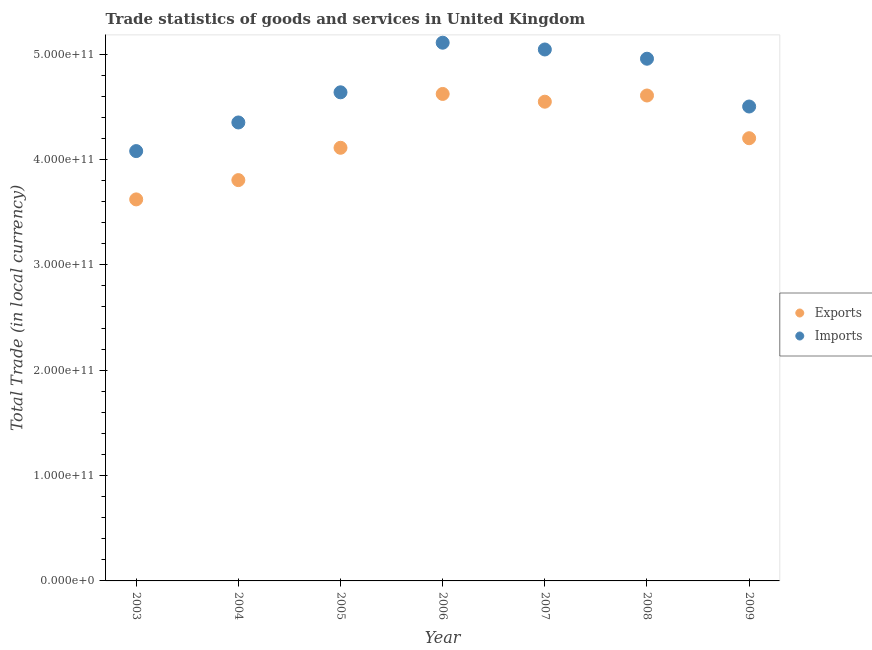What is the export of goods and services in 2008?
Make the answer very short. 4.61e+11. Across all years, what is the maximum export of goods and services?
Your answer should be very brief. 4.62e+11. Across all years, what is the minimum export of goods and services?
Give a very brief answer. 3.62e+11. In which year was the imports of goods and services maximum?
Your response must be concise. 2006. What is the total imports of goods and services in the graph?
Keep it short and to the point. 3.27e+12. What is the difference between the export of goods and services in 2006 and that in 2009?
Ensure brevity in your answer.  4.20e+1. What is the difference between the export of goods and services in 2007 and the imports of goods and services in 2006?
Your answer should be compact. -5.60e+1. What is the average export of goods and services per year?
Your response must be concise. 4.22e+11. In the year 2009, what is the difference between the export of goods and services and imports of goods and services?
Provide a succinct answer. -3.01e+1. In how many years, is the export of goods and services greater than 180000000000 LCU?
Ensure brevity in your answer.  7. What is the ratio of the export of goods and services in 2003 to that in 2004?
Give a very brief answer. 0.95. Is the export of goods and services in 2005 less than that in 2009?
Keep it short and to the point. Yes. Is the difference between the export of goods and services in 2004 and 2009 greater than the difference between the imports of goods and services in 2004 and 2009?
Offer a terse response. No. What is the difference between the highest and the second highest imports of goods and services?
Make the answer very short. 6.43e+09. What is the difference between the highest and the lowest export of goods and services?
Your answer should be very brief. 1.00e+11. Is the export of goods and services strictly greater than the imports of goods and services over the years?
Keep it short and to the point. No. How many dotlines are there?
Your answer should be compact. 2. What is the difference between two consecutive major ticks on the Y-axis?
Provide a succinct answer. 1.00e+11. Does the graph contain any zero values?
Give a very brief answer. No. How are the legend labels stacked?
Offer a terse response. Vertical. What is the title of the graph?
Provide a succinct answer. Trade statistics of goods and services in United Kingdom. Does "Chemicals" appear as one of the legend labels in the graph?
Provide a short and direct response. No. What is the label or title of the X-axis?
Provide a short and direct response. Year. What is the label or title of the Y-axis?
Provide a succinct answer. Total Trade (in local currency). What is the Total Trade (in local currency) of Exports in 2003?
Provide a short and direct response. 3.62e+11. What is the Total Trade (in local currency) of Imports in 2003?
Give a very brief answer. 4.08e+11. What is the Total Trade (in local currency) of Exports in 2004?
Give a very brief answer. 3.80e+11. What is the Total Trade (in local currency) in Imports in 2004?
Offer a very short reply. 4.35e+11. What is the Total Trade (in local currency) in Exports in 2005?
Offer a very short reply. 4.11e+11. What is the Total Trade (in local currency) of Imports in 2005?
Give a very brief answer. 4.64e+11. What is the Total Trade (in local currency) in Exports in 2006?
Keep it short and to the point. 4.62e+11. What is the Total Trade (in local currency) in Imports in 2006?
Keep it short and to the point. 5.11e+11. What is the Total Trade (in local currency) of Exports in 2007?
Ensure brevity in your answer.  4.55e+11. What is the Total Trade (in local currency) of Imports in 2007?
Your response must be concise. 5.04e+11. What is the Total Trade (in local currency) of Exports in 2008?
Provide a succinct answer. 4.61e+11. What is the Total Trade (in local currency) of Imports in 2008?
Keep it short and to the point. 4.96e+11. What is the Total Trade (in local currency) in Exports in 2009?
Your response must be concise. 4.20e+11. What is the Total Trade (in local currency) of Imports in 2009?
Make the answer very short. 4.50e+11. Across all years, what is the maximum Total Trade (in local currency) of Exports?
Offer a very short reply. 4.62e+11. Across all years, what is the maximum Total Trade (in local currency) of Imports?
Your answer should be compact. 5.11e+11. Across all years, what is the minimum Total Trade (in local currency) of Exports?
Ensure brevity in your answer.  3.62e+11. Across all years, what is the minimum Total Trade (in local currency) in Imports?
Keep it short and to the point. 4.08e+11. What is the total Total Trade (in local currency) in Exports in the graph?
Offer a very short reply. 2.95e+12. What is the total Total Trade (in local currency) of Imports in the graph?
Provide a succinct answer. 3.27e+12. What is the difference between the Total Trade (in local currency) of Exports in 2003 and that in 2004?
Your answer should be compact. -1.83e+1. What is the difference between the Total Trade (in local currency) in Imports in 2003 and that in 2004?
Offer a terse response. -2.72e+1. What is the difference between the Total Trade (in local currency) in Exports in 2003 and that in 2005?
Provide a succinct answer. -4.90e+1. What is the difference between the Total Trade (in local currency) in Imports in 2003 and that in 2005?
Make the answer very short. -5.58e+1. What is the difference between the Total Trade (in local currency) in Exports in 2003 and that in 2006?
Make the answer very short. -1.00e+11. What is the difference between the Total Trade (in local currency) in Imports in 2003 and that in 2006?
Make the answer very short. -1.03e+11. What is the difference between the Total Trade (in local currency) of Exports in 2003 and that in 2007?
Provide a short and direct response. -9.27e+1. What is the difference between the Total Trade (in local currency) in Imports in 2003 and that in 2007?
Your response must be concise. -9.64e+1. What is the difference between the Total Trade (in local currency) in Exports in 2003 and that in 2008?
Give a very brief answer. -9.86e+1. What is the difference between the Total Trade (in local currency) in Imports in 2003 and that in 2008?
Your response must be concise. -8.77e+1. What is the difference between the Total Trade (in local currency) in Exports in 2003 and that in 2009?
Ensure brevity in your answer.  -5.81e+1. What is the difference between the Total Trade (in local currency) of Imports in 2003 and that in 2009?
Provide a succinct answer. -4.23e+1. What is the difference between the Total Trade (in local currency) of Exports in 2004 and that in 2005?
Your response must be concise. -3.07e+1. What is the difference between the Total Trade (in local currency) in Imports in 2004 and that in 2005?
Give a very brief answer. -2.86e+1. What is the difference between the Total Trade (in local currency) of Exports in 2004 and that in 2006?
Provide a succinct answer. -8.18e+1. What is the difference between the Total Trade (in local currency) of Imports in 2004 and that in 2006?
Your answer should be very brief. -7.57e+1. What is the difference between the Total Trade (in local currency) in Exports in 2004 and that in 2007?
Provide a succinct answer. -7.44e+1. What is the difference between the Total Trade (in local currency) in Imports in 2004 and that in 2007?
Keep it short and to the point. -6.93e+1. What is the difference between the Total Trade (in local currency) in Exports in 2004 and that in 2008?
Your answer should be compact. -8.03e+1. What is the difference between the Total Trade (in local currency) in Imports in 2004 and that in 2008?
Provide a succinct answer. -6.05e+1. What is the difference between the Total Trade (in local currency) of Exports in 2004 and that in 2009?
Your response must be concise. -3.98e+1. What is the difference between the Total Trade (in local currency) in Imports in 2004 and that in 2009?
Give a very brief answer. -1.51e+1. What is the difference between the Total Trade (in local currency) of Exports in 2005 and that in 2006?
Your response must be concise. -5.11e+1. What is the difference between the Total Trade (in local currency) of Imports in 2005 and that in 2006?
Ensure brevity in your answer.  -4.71e+1. What is the difference between the Total Trade (in local currency) of Exports in 2005 and that in 2007?
Provide a short and direct response. -4.37e+1. What is the difference between the Total Trade (in local currency) of Imports in 2005 and that in 2007?
Your answer should be very brief. -4.07e+1. What is the difference between the Total Trade (in local currency) of Exports in 2005 and that in 2008?
Your response must be concise. -4.96e+1. What is the difference between the Total Trade (in local currency) in Imports in 2005 and that in 2008?
Give a very brief answer. -3.19e+1. What is the difference between the Total Trade (in local currency) of Exports in 2005 and that in 2009?
Keep it short and to the point. -9.08e+09. What is the difference between the Total Trade (in local currency) in Imports in 2005 and that in 2009?
Provide a succinct answer. 1.35e+1. What is the difference between the Total Trade (in local currency) of Exports in 2006 and that in 2007?
Provide a succinct answer. 7.36e+09. What is the difference between the Total Trade (in local currency) of Imports in 2006 and that in 2007?
Offer a very short reply. 6.43e+09. What is the difference between the Total Trade (in local currency) of Exports in 2006 and that in 2008?
Ensure brevity in your answer.  1.47e+09. What is the difference between the Total Trade (in local currency) in Imports in 2006 and that in 2008?
Make the answer very short. 1.52e+1. What is the difference between the Total Trade (in local currency) of Exports in 2006 and that in 2009?
Your response must be concise. 4.20e+1. What is the difference between the Total Trade (in local currency) in Imports in 2006 and that in 2009?
Ensure brevity in your answer.  6.06e+1. What is the difference between the Total Trade (in local currency) in Exports in 2007 and that in 2008?
Offer a terse response. -5.89e+09. What is the difference between the Total Trade (in local currency) of Imports in 2007 and that in 2008?
Provide a succinct answer. 8.77e+09. What is the difference between the Total Trade (in local currency) in Exports in 2007 and that in 2009?
Offer a terse response. 3.47e+1. What is the difference between the Total Trade (in local currency) of Imports in 2007 and that in 2009?
Your answer should be compact. 5.41e+1. What is the difference between the Total Trade (in local currency) of Exports in 2008 and that in 2009?
Your response must be concise. 4.05e+1. What is the difference between the Total Trade (in local currency) of Imports in 2008 and that in 2009?
Provide a short and direct response. 4.54e+1. What is the difference between the Total Trade (in local currency) in Exports in 2003 and the Total Trade (in local currency) in Imports in 2004?
Offer a very short reply. -7.30e+1. What is the difference between the Total Trade (in local currency) of Exports in 2003 and the Total Trade (in local currency) of Imports in 2005?
Your answer should be very brief. -1.02e+11. What is the difference between the Total Trade (in local currency) of Exports in 2003 and the Total Trade (in local currency) of Imports in 2006?
Ensure brevity in your answer.  -1.49e+11. What is the difference between the Total Trade (in local currency) in Exports in 2003 and the Total Trade (in local currency) in Imports in 2007?
Make the answer very short. -1.42e+11. What is the difference between the Total Trade (in local currency) in Exports in 2003 and the Total Trade (in local currency) in Imports in 2008?
Give a very brief answer. -1.34e+11. What is the difference between the Total Trade (in local currency) in Exports in 2003 and the Total Trade (in local currency) in Imports in 2009?
Your answer should be very brief. -8.82e+1. What is the difference between the Total Trade (in local currency) of Exports in 2004 and the Total Trade (in local currency) of Imports in 2005?
Provide a short and direct response. -8.33e+1. What is the difference between the Total Trade (in local currency) in Exports in 2004 and the Total Trade (in local currency) in Imports in 2006?
Your response must be concise. -1.30e+11. What is the difference between the Total Trade (in local currency) of Exports in 2004 and the Total Trade (in local currency) of Imports in 2007?
Make the answer very short. -1.24e+11. What is the difference between the Total Trade (in local currency) of Exports in 2004 and the Total Trade (in local currency) of Imports in 2008?
Provide a succinct answer. -1.15e+11. What is the difference between the Total Trade (in local currency) of Exports in 2004 and the Total Trade (in local currency) of Imports in 2009?
Provide a short and direct response. -6.98e+1. What is the difference between the Total Trade (in local currency) of Exports in 2005 and the Total Trade (in local currency) of Imports in 2006?
Make the answer very short. -9.97e+1. What is the difference between the Total Trade (in local currency) in Exports in 2005 and the Total Trade (in local currency) in Imports in 2007?
Provide a succinct answer. -9.33e+1. What is the difference between the Total Trade (in local currency) in Exports in 2005 and the Total Trade (in local currency) in Imports in 2008?
Your answer should be very brief. -8.45e+1. What is the difference between the Total Trade (in local currency) in Exports in 2005 and the Total Trade (in local currency) in Imports in 2009?
Your answer should be compact. -3.92e+1. What is the difference between the Total Trade (in local currency) of Exports in 2006 and the Total Trade (in local currency) of Imports in 2007?
Ensure brevity in your answer.  -4.22e+1. What is the difference between the Total Trade (in local currency) of Exports in 2006 and the Total Trade (in local currency) of Imports in 2008?
Offer a very short reply. -3.34e+1. What is the difference between the Total Trade (in local currency) in Exports in 2006 and the Total Trade (in local currency) in Imports in 2009?
Make the answer very short. 1.19e+1. What is the difference between the Total Trade (in local currency) in Exports in 2007 and the Total Trade (in local currency) in Imports in 2008?
Ensure brevity in your answer.  -4.08e+1. What is the difference between the Total Trade (in local currency) in Exports in 2007 and the Total Trade (in local currency) in Imports in 2009?
Give a very brief answer. 4.57e+09. What is the difference between the Total Trade (in local currency) in Exports in 2008 and the Total Trade (in local currency) in Imports in 2009?
Offer a very short reply. 1.05e+1. What is the average Total Trade (in local currency) of Exports per year?
Your response must be concise. 4.22e+11. What is the average Total Trade (in local currency) in Imports per year?
Your answer should be compact. 4.67e+11. In the year 2003, what is the difference between the Total Trade (in local currency) in Exports and Total Trade (in local currency) in Imports?
Provide a short and direct response. -4.58e+1. In the year 2004, what is the difference between the Total Trade (in local currency) of Exports and Total Trade (in local currency) of Imports?
Provide a short and direct response. -5.47e+1. In the year 2005, what is the difference between the Total Trade (in local currency) in Exports and Total Trade (in local currency) in Imports?
Provide a short and direct response. -5.26e+1. In the year 2006, what is the difference between the Total Trade (in local currency) of Exports and Total Trade (in local currency) of Imports?
Provide a short and direct response. -4.86e+1. In the year 2007, what is the difference between the Total Trade (in local currency) in Exports and Total Trade (in local currency) in Imports?
Offer a terse response. -4.96e+1. In the year 2008, what is the difference between the Total Trade (in local currency) of Exports and Total Trade (in local currency) of Imports?
Provide a short and direct response. -3.49e+1. In the year 2009, what is the difference between the Total Trade (in local currency) of Exports and Total Trade (in local currency) of Imports?
Provide a succinct answer. -3.01e+1. What is the ratio of the Total Trade (in local currency) of Exports in 2003 to that in 2004?
Provide a short and direct response. 0.95. What is the ratio of the Total Trade (in local currency) in Imports in 2003 to that in 2004?
Offer a terse response. 0.94. What is the ratio of the Total Trade (in local currency) of Exports in 2003 to that in 2005?
Offer a terse response. 0.88. What is the ratio of the Total Trade (in local currency) of Imports in 2003 to that in 2005?
Ensure brevity in your answer.  0.88. What is the ratio of the Total Trade (in local currency) of Exports in 2003 to that in 2006?
Give a very brief answer. 0.78. What is the ratio of the Total Trade (in local currency) of Imports in 2003 to that in 2006?
Your answer should be very brief. 0.8. What is the ratio of the Total Trade (in local currency) in Exports in 2003 to that in 2007?
Offer a terse response. 0.8. What is the ratio of the Total Trade (in local currency) of Imports in 2003 to that in 2007?
Give a very brief answer. 0.81. What is the ratio of the Total Trade (in local currency) in Exports in 2003 to that in 2008?
Give a very brief answer. 0.79. What is the ratio of the Total Trade (in local currency) in Imports in 2003 to that in 2008?
Offer a very short reply. 0.82. What is the ratio of the Total Trade (in local currency) in Exports in 2003 to that in 2009?
Your answer should be compact. 0.86. What is the ratio of the Total Trade (in local currency) in Imports in 2003 to that in 2009?
Give a very brief answer. 0.91. What is the ratio of the Total Trade (in local currency) in Exports in 2004 to that in 2005?
Make the answer very short. 0.93. What is the ratio of the Total Trade (in local currency) in Imports in 2004 to that in 2005?
Make the answer very short. 0.94. What is the ratio of the Total Trade (in local currency) in Exports in 2004 to that in 2006?
Offer a very short reply. 0.82. What is the ratio of the Total Trade (in local currency) of Imports in 2004 to that in 2006?
Keep it short and to the point. 0.85. What is the ratio of the Total Trade (in local currency) in Exports in 2004 to that in 2007?
Give a very brief answer. 0.84. What is the ratio of the Total Trade (in local currency) in Imports in 2004 to that in 2007?
Provide a succinct answer. 0.86. What is the ratio of the Total Trade (in local currency) in Exports in 2004 to that in 2008?
Provide a short and direct response. 0.83. What is the ratio of the Total Trade (in local currency) of Imports in 2004 to that in 2008?
Provide a short and direct response. 0.88. What is the ratio of the Total Trade (in local currency) in Exports in 2004 to that in 2009?
Offer a very short reply. 0.91. What is the ratio of the Total Trade (in local currency) in Imports in 2004 to that in 2009?
Offer a very short reply. 0.97. What is the ratio of the Total Trade (in local currency) in Exports in 2005 to that in 2006?
Your response must be concise. 0.89. What is the ratio of the Total Trade (in local currency) in Imports in 2005 to that in 2006?
Provide a succinct answer. 0.91. What is the ratio of the Total Trade (in local currency) of Exports in 2005 to that in 2007?
Make the answer very short. 0.9. What is the ratio of the Total Trade (in local currency) of Imports in 2005 to that in 2007?
Offer a very short reply. 0.92. What is the ratio of the Total Trade (in local currency) in Exports in 2005 to that in 2008?
Ensure brevity in your answer.  0.89. What is the ratio of the Total Trade (in local currency) of Imports in 2005 to that in 2008?
Your answer should be compact. 0.94. What is the ratio of the Total Trade (in local currency) in Exports in 2005 to that in 2009?
Give a very brief answer. 0.98. What is the ratio of the Total Trade (in local currency) in Imports in 2005 to that in 2009?
Your answer should be compact. 1.03. What is the ratio of the Total Trade (in local currency) in Exports in 2006 to that in 2007?
Provide a succinct answer. 1.02. What is the ratio of the Total Trade (in local currency) in Imports in 2006 to that in 2007?
Make the answer very short. 1.01. What is the ratio of the Total Trade (in local currency) of Exports in 2006 to that in 2008?
Offer a very short reply. 1. What is the ratio of the Total Trade (in local currency) of Imports in 2006 to that in 2008?
Offer a very short reply. 1.03. What is the ratio of the Total Trade (in local currency) of Imports in 2006 to that in 2009?
Make the answer very short. 1.13. What is the ratio of the Total Trade (in local currency) of Exports in 2007 to that in 2008?
Your answer should be very brief. 0.99. What is the ratio of the Total Trade (in local currency) of Imports in 2007 to that in 2008?
Your response must be concise. 1.02. What is the ratio of the Total Trade (in local currency) in Exports in 2007 to that in 2009?
Keep it short and to the point. 1.08. What is the ratio of the Total Trade (in local currency) in Imports in 2007 to that in 2009?
Your answer should be very brief. 1.12. What is the ratio of the Total Trade (in local currency) of Exports in 2008 to that in 2009?
Your answer should be very brief. 1.1. What is the ratio of the Total Trade (in local currency) of Imports in 2008 to that in 2009?
Keep it short and to the point. 1.1. What is the difference between the highest and the second highest Total Trade (in local currency) in Exports?
Provide a succinct answer. 1.47e+09. What is the difference between the highest and the second highest Total Trade (in local currency) of Imports?
Offer a terse response. 6.43e+09. What is the difference between the highest and the lowest Total Trade (in local currency) of Exports?
Give a very brief answer. 1.00e+11. What is the difference between the highest and the lowest Total Trade (in local currency) in Imports?
Offer a terse response. 1.03e+11. 